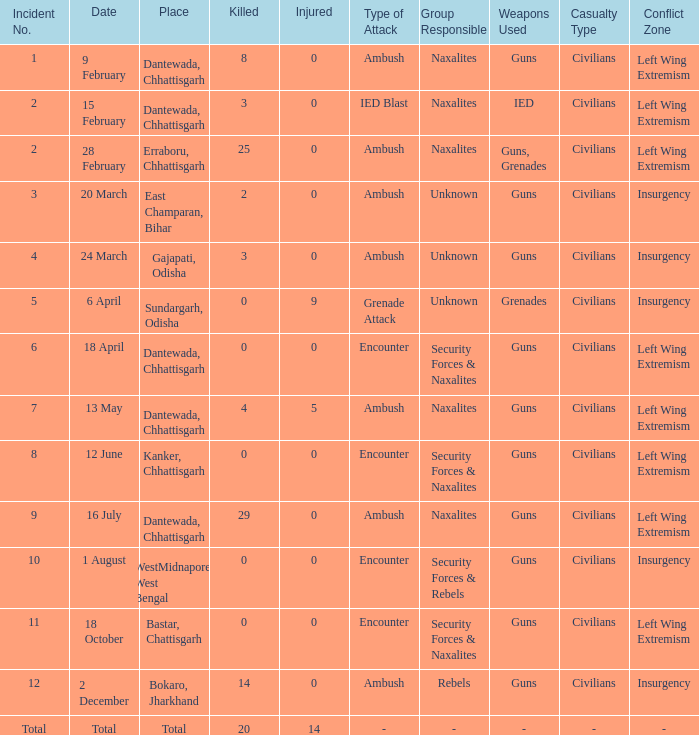What is the least amount of injuries in Dantewada, Chhattisgarh when 8 people were killed? 0.0. Could you parse the entire table? {'header': ['Incident No.', 'Date', 'Place', 'Killed', 'Injured', 'Type of Attack', 'Group Responsible', 'Weapons Used', 'Casualty Type', 'Conflict Zone'], 'rows': [['1', '9 February', 'Dantewada, Chhattisgarh', '8', '0', 'Ambush', 'Naxalites', 'Guns', 'Civilians', 'Left Wing Extremism'], ['2', '15 February', 'Dantewada, Chhattisgarh', '3', '0', 'IED Blast', 'Naxalites', 'IED', 'Civilians', 'Left Wing Extremism'], ['2', '28 February', 'Erraboru, Chhattisgarh', '25', '0', 'Ambush', 'Naxalites', 'Guns, Grenades', 'Civilians', 'Left Wing Extremism'], ['3', '20 March', 'East Champaran, Bihar', '2', '0', 'Ambush', 'Unknown', 'Guns', 'Civilians', 'Insurgency'], ['4', '24 March', 'Gajapati, Odisha', '3', '0', 'Ambush', 'Unknown', 'Guns', 'Civilians', 'Insurgency'], ['5', '6 April', 'Sundargarh, Odisha', '0', '9', 'Grenade Attack', 'Unknown', 'Grenades', 'Civilians', 'Insurgency'], ['6', '18 April', 'Dantewada, Chhattisgarh', '0', '0', 'Encounter', 'Security Forces & Naxalites', 'Guns', 'Civilians', 'Left Wing Extremism'], ['7', '13 May', 'Dantewada, Chhattisgarh', '4', '5', 'Ambush', 'Naxalites', 'Guns', 'Civilians', 'Left Wing Extremism'], ['8', '12 June', 'Kanker, Chhattisgarh', '0', '0', 'Encounter', 'Security Forces & Naxalites', 'Guns', 'Civilians', 'Left Wing Extremism'], ['9', '16 July', 'Dantewada, Chhattisgarh', '29', '0', 'Ambush', 'Naxalites', 'Guns', 'Civilians', 'Left Wing Extremism'], ['10', '1 August', 'WestMidnapore, West Bengal', '0', '0', 'Encounter', 'Security Forces & Rebels', 'Guns', 'Civilians', 'Insurgency'], ['11', '18 October', 'Bastar, Chattisgarh', '0', '0', 'Encounter', 'Security Forces & Naxalites', 'Guns', 'Civilians', 'Left Wing Extremism'], ['12', '2 December', 'Bokaro, Jharkhand', '14', '0', 'Ambush', 'Rebels', 'Guns', 'Civilians', 'Insurgency'], ['Total', 'Total', 'Total', '20', '14', '-', '-', '-', '-', '-']]} 